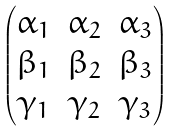<formula> <loc_0><loc_0><loc_500><loc_500>\begin{pmatrix} \alpha _ { 1 } & \alpha _ { 2 } & \alpha _ { 3 } \\ \beta _ { 1 } & \beta _ { 2 } & \beta _ { 3 } \\ \gamma _ { 1 } & \gamma _ { 2 } & \gamma _ { 3 } \end{pmatrix}</formula> 